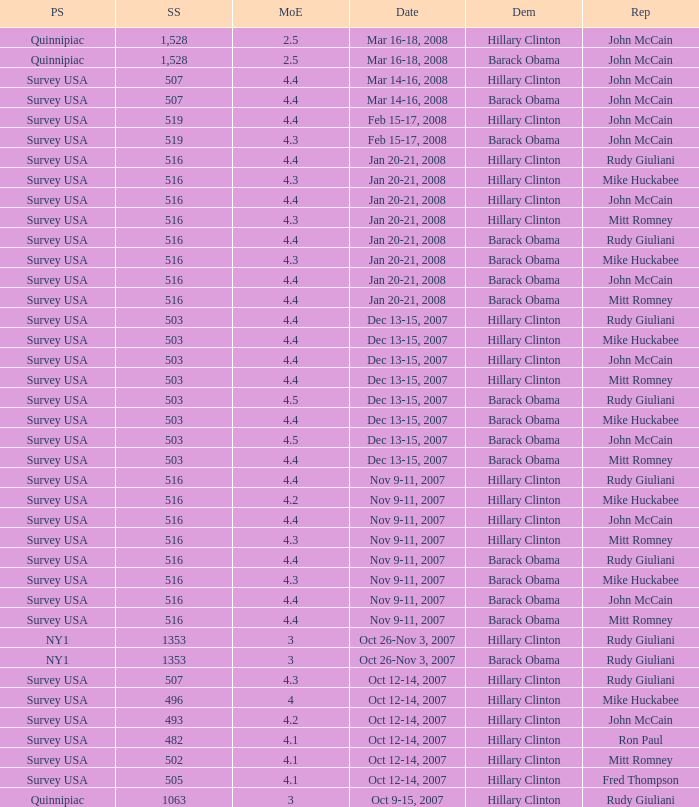Which Democrat was selected in the poll with a sample size smaller than 516 where the Republican chosen was Ron Paul? Hillary Clinton. Help me parse the entirety of this table. {'header': ['PS', 'SS', 'MoE', 'Date', 'Dem', 'Rep'], 'rows': [['Quinnipiac', '1,528', '2.5', 'Mar 16-18, 2008', 'Hillary Clinton', 'John McCain'], ['Quinnipiac', '1,528', '2.5', 'Mar 16-18, 2008', 'Barack Obama', 'John McCain'], ['Survey USA', '507', '4.4', 'Mar 14-16, 2008', 'Hillary Clinton', 'John McCain'], ['Survey USA', '507', '4.4', 'Mar 14-16, 2008', 'Barack Obama', 'John McCain'], ['Survey USA', '519', '4.4', 'Feb 15-17, 2008', 'Hillary Clinton', 'John McCain'], ['Survey USA', '519', '4.3', 'Feb 15-17, 2008', 'Barack Obama', 'John McCain'], ['Survey USA', '516', '4.4', 'Jan 20-21, 2008', 'Hillary Clinton', 'Rudy Giuliani'], ['Survey USA', '516', '4.3', 'Jan 20-21, 2008', 'Hillary Clinton', 'Mike Huckabee'], ['Survey USA', '516', '4.4', 'Jan 20-21, 2008', 'Hillary Clinton', 'John McCain'], ['Survey USA', '516', '4.3', 'Jan 20-21, 2008', 'Hillary Clinton', 'Mitt Romney'], ['Survey USA', '516', '4.4', 'Jan 20-21, 2008', 'Barack Obama', 'Rudy Giuliani'], ['Survey USA', '516', '4.3', 'Jan 20-21, 2008', 'Barack Obama', 'Mike Huckabee'], ['Survey USA', '516', '4.4', 'Jan 20-21, 2008', 'Barack Obama', 'John McCain'], ['Survey USA', '516', '4.4', 'Jan 20-21, 2008', 'Barack Obama', 'Mitt Romney'], ['Survey USA', '503', '4.4', 'Dec 13-15, 2007', 'Hillary Clinton', 'Rudy Giuliani'], ['Survey USA', '503', '4.4', 'Dec 13-15, 2007', 'Hillary Clinton', 'Mike Huckabee'], ['Survey USA', '503', '4.4', 'Dec 13-15, 2007', 'Hillary Clinton', 'John McCain'], ['Survey USA', '503', '4.4', 'Dec 13-15, 2007', 'Hillary Clinton', 'Mitt Romney'], ['Survey USA', '503', '4.5', 'Dec 13-15, 2007', 'Barack Obama', 'Rudy Giuliani'], ['Survey USA', '503', '4.4', 'Dec 13-15, 2007', 'Barack Obama', 'Mike Huckabee'], ['Survey USA', '503', '4.5', 'Dec 13-15, 2007', 'Barack Obama', 'John McCain'], ['Survey USA', '503', '4.4', 'Dec 13-15, 2007', 'Barack Obama', 'Mitt Romney'], ['Survey USA', '516', '4.4', 'Nov 9-11, 2007', 'Hillary Clinton', 'Rudy Giuliani'], ['Survey USA', '516', '4.2', 'Nov 9-11, 2007', 'Hillary Clinton', 'Mike Huckabee'], ['Survey USA', '516', '4.4', 'Nov 9-11, 2007', 'Hillary Clinton', 'John McCain'], ['Survey USA', '516', '4.3', 'Nov 9-11, 2007', 'Hillary Clinton', 'Mitt Romney'], ['Survey USA', '516', '4.4', 'Nov 9-11, 2007', 'Barack Obama', 'Rudy Giuliani'], ['Survey USA', '516', '4.3', 'Nov 9-11, 2007', 'Barack Obama', 'Mike Huckabee'], ['Survey USA', '516', '4.4', 'Nov 9-11, 2007', 'Barack Obama', 'John McCain'], ['Survey USA', '516', '4.4', 'Nov 9-11, 2007', 'Barack Obama', 'Mitt Romney'], ['NY1', '1353', '3', 'Oct 26-Nov 3, 2007', 'Hillary Clinton', 'Rudy Giuliani'], ['NY1', '1353', '3', 'Oct 26-Nov 3, 2007', 'Barack Obama', 'Rudy Giuliani'], ['Survey USA', '507', '4.3', 'Oct 12-14, 2007', 'Hillary Clinton', 'Rudy Giuliani'], ['Survey USA', '496', '4', 'Oct 12-14, 2007', 'Hillary Clinton', 'Mike Huckabee'], ['Survey USA', '493', '4.2', 'Oct 12-14, 2007', 'Hillary Clinton', 'John McCain'], ['Survey USA', '482', '4.1', 'Oct 12-14, 2007', 'Hillary Clinton', 'Ron Paul'], ['Survey USA', '502', '4.1', 'Oct 12-14, 2007', 'Hillary Clinton', 'Mitt Romney'], ['Survey USA', '505', '4.1', 'Oct 12-14, 2007', 'Hillary Clinton', 'Fred Thompson'], ['Quinnipiac', '1063', '3', 'Oct 9-15, 2007', 'Hillary Clinton', 'Rudy Giuliani']]} 